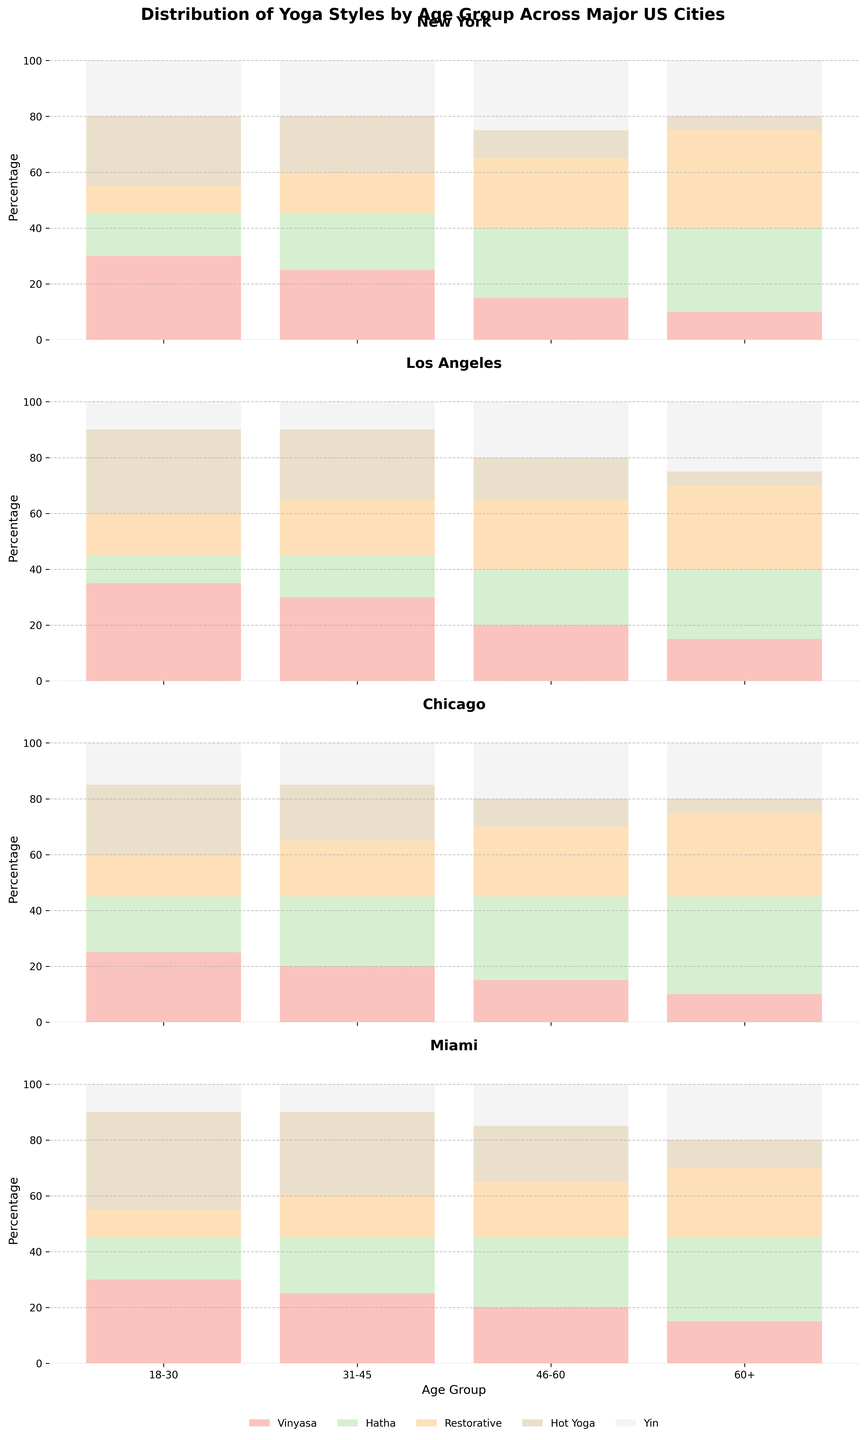What is the title of the figure? The title is usually displayed at the top center of the figure in larger bold font. In this case, it reads 'Distribution of Yoga Styles by Age Group Across Major US Cities'
Answer: Distribution of Yoga Styles by Age Group Across Major US Cities Which city has the highest percentage of 'Hot Yoga' practitioners in the age group 18-30? For each city, I need to identify the bar segment labeled 'Hot Yoga' within the 18-30 age group. From visual inspection, New York has 25%, Los Angeles 30%, Chicago 25%, and Miami 35%. The highest percentage is in Miami
Answer: Miami How does the percentage of 'Restorative Yoga' practitioners in New York compare between the age groups 31-45 and 46-60? For New York, I look at the bar segments for 'Restorative Yoga' in the 31-45 age group (15%) and the 46-60 age group (25%). Comparing these, there are more practitioners in the 46-60 age group
Answer: The percentage is higher in the 46-60 age group Which age group in Chicago shows the highest preference for 'Hatha Yoga'? For each age group in Chicago, I identify the bar segment labeled 'Hatha Yoga'. The percentages are 20% for 18-30, 25% for 31-45, 30% for 46-60, and 35% for 60+. The highest percentage is for the 60+ age group
Answer: 60+ What is the combined percentage of 'Vinyasa Yoga' practitioners in Los Angeles across all age groups? I need to sum the 'Vinyasa' percentages across all age groups in Los Angeles: 35% (18-30) + 30% (31-45) + 20% (46-60) + 15% (60+). Combining these gives a total of 100%
Answer: 100% Which yoga style shows a consistent increase in preference with age in Miami? For each age group in Miami, I look at the percentages for each yoga style and check for consistent increase. 'Hatha Yoga' starts at 15% for 18-30, then 20% for 31-45, 25% for 46-60, and 30% for 60+, indicating a consistent increase
Answer: Hatha Yoga What stands out about the age group 60+ in New York in terms of 'Restorative Yoga'? Observing the figure, the age group 60+ in New York has a standout percentage of 35% for 'Restorative Yoga', which is noticeably higher than other styles within the same age group. This indicates a strong preference for this style among older practitioners
Answer: High preference for Restorative Yoga Which city has the largest total percentage of 'Yin Yoga' practitioners for the age group 31-45? I need to identify the bar segment for 'Yin Yoga' within the 31-45 age group in each city and compare them. New York has 20%, Los Angeles 10%, Chicago 15%, and Miami 10%. New York has the largest total percentage
Answer: New York 